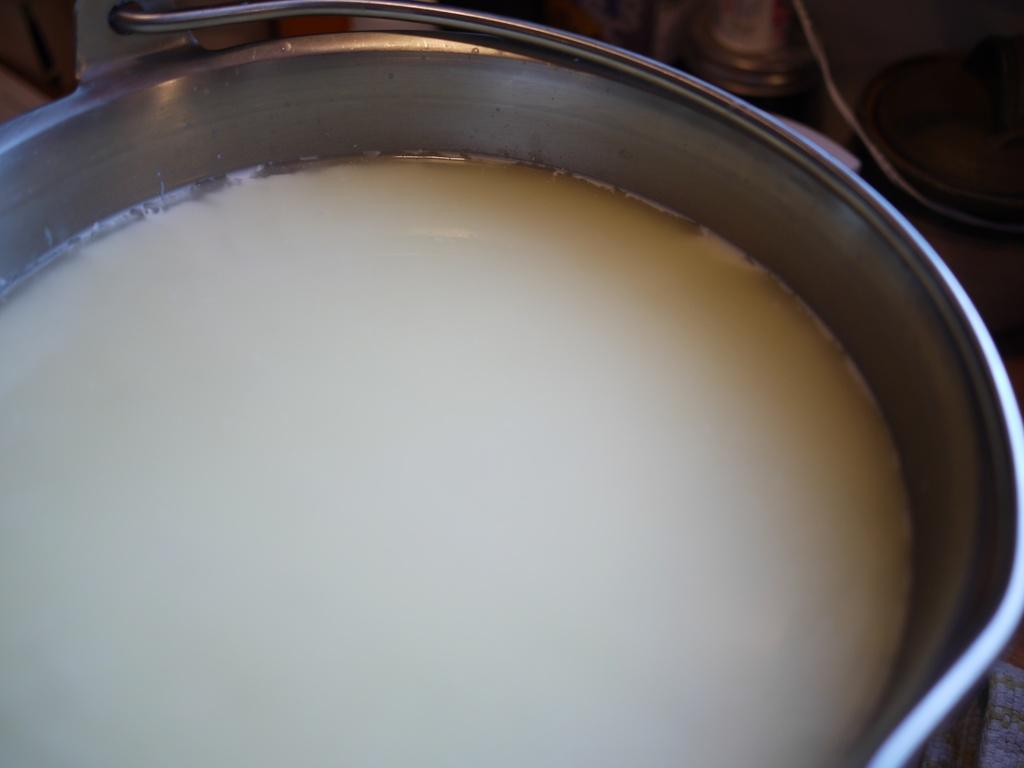What type of container is present in the image? There is a steel bucket in the image. What is inside the container? There is a white color liquid in the bucket. Where is the nearest library to the location of the steel bucket in the image? The provided facts do not give any information about the location of the steel bucket or the nearest library, so it cannot be determined from the image. 